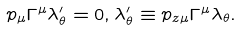<formula> <loc_0><loc_0><loc_500><loc_500>p _ { \mu } \Gamma ^ { \mu } \lambda _ { \theta } ^ { \prime } = 0 , \lambda _ { \theta } ^ { \prime } \equiv p _ { z \mu } \Gamma ^ { \mu } \lambda _ { \theta } .</formula> 